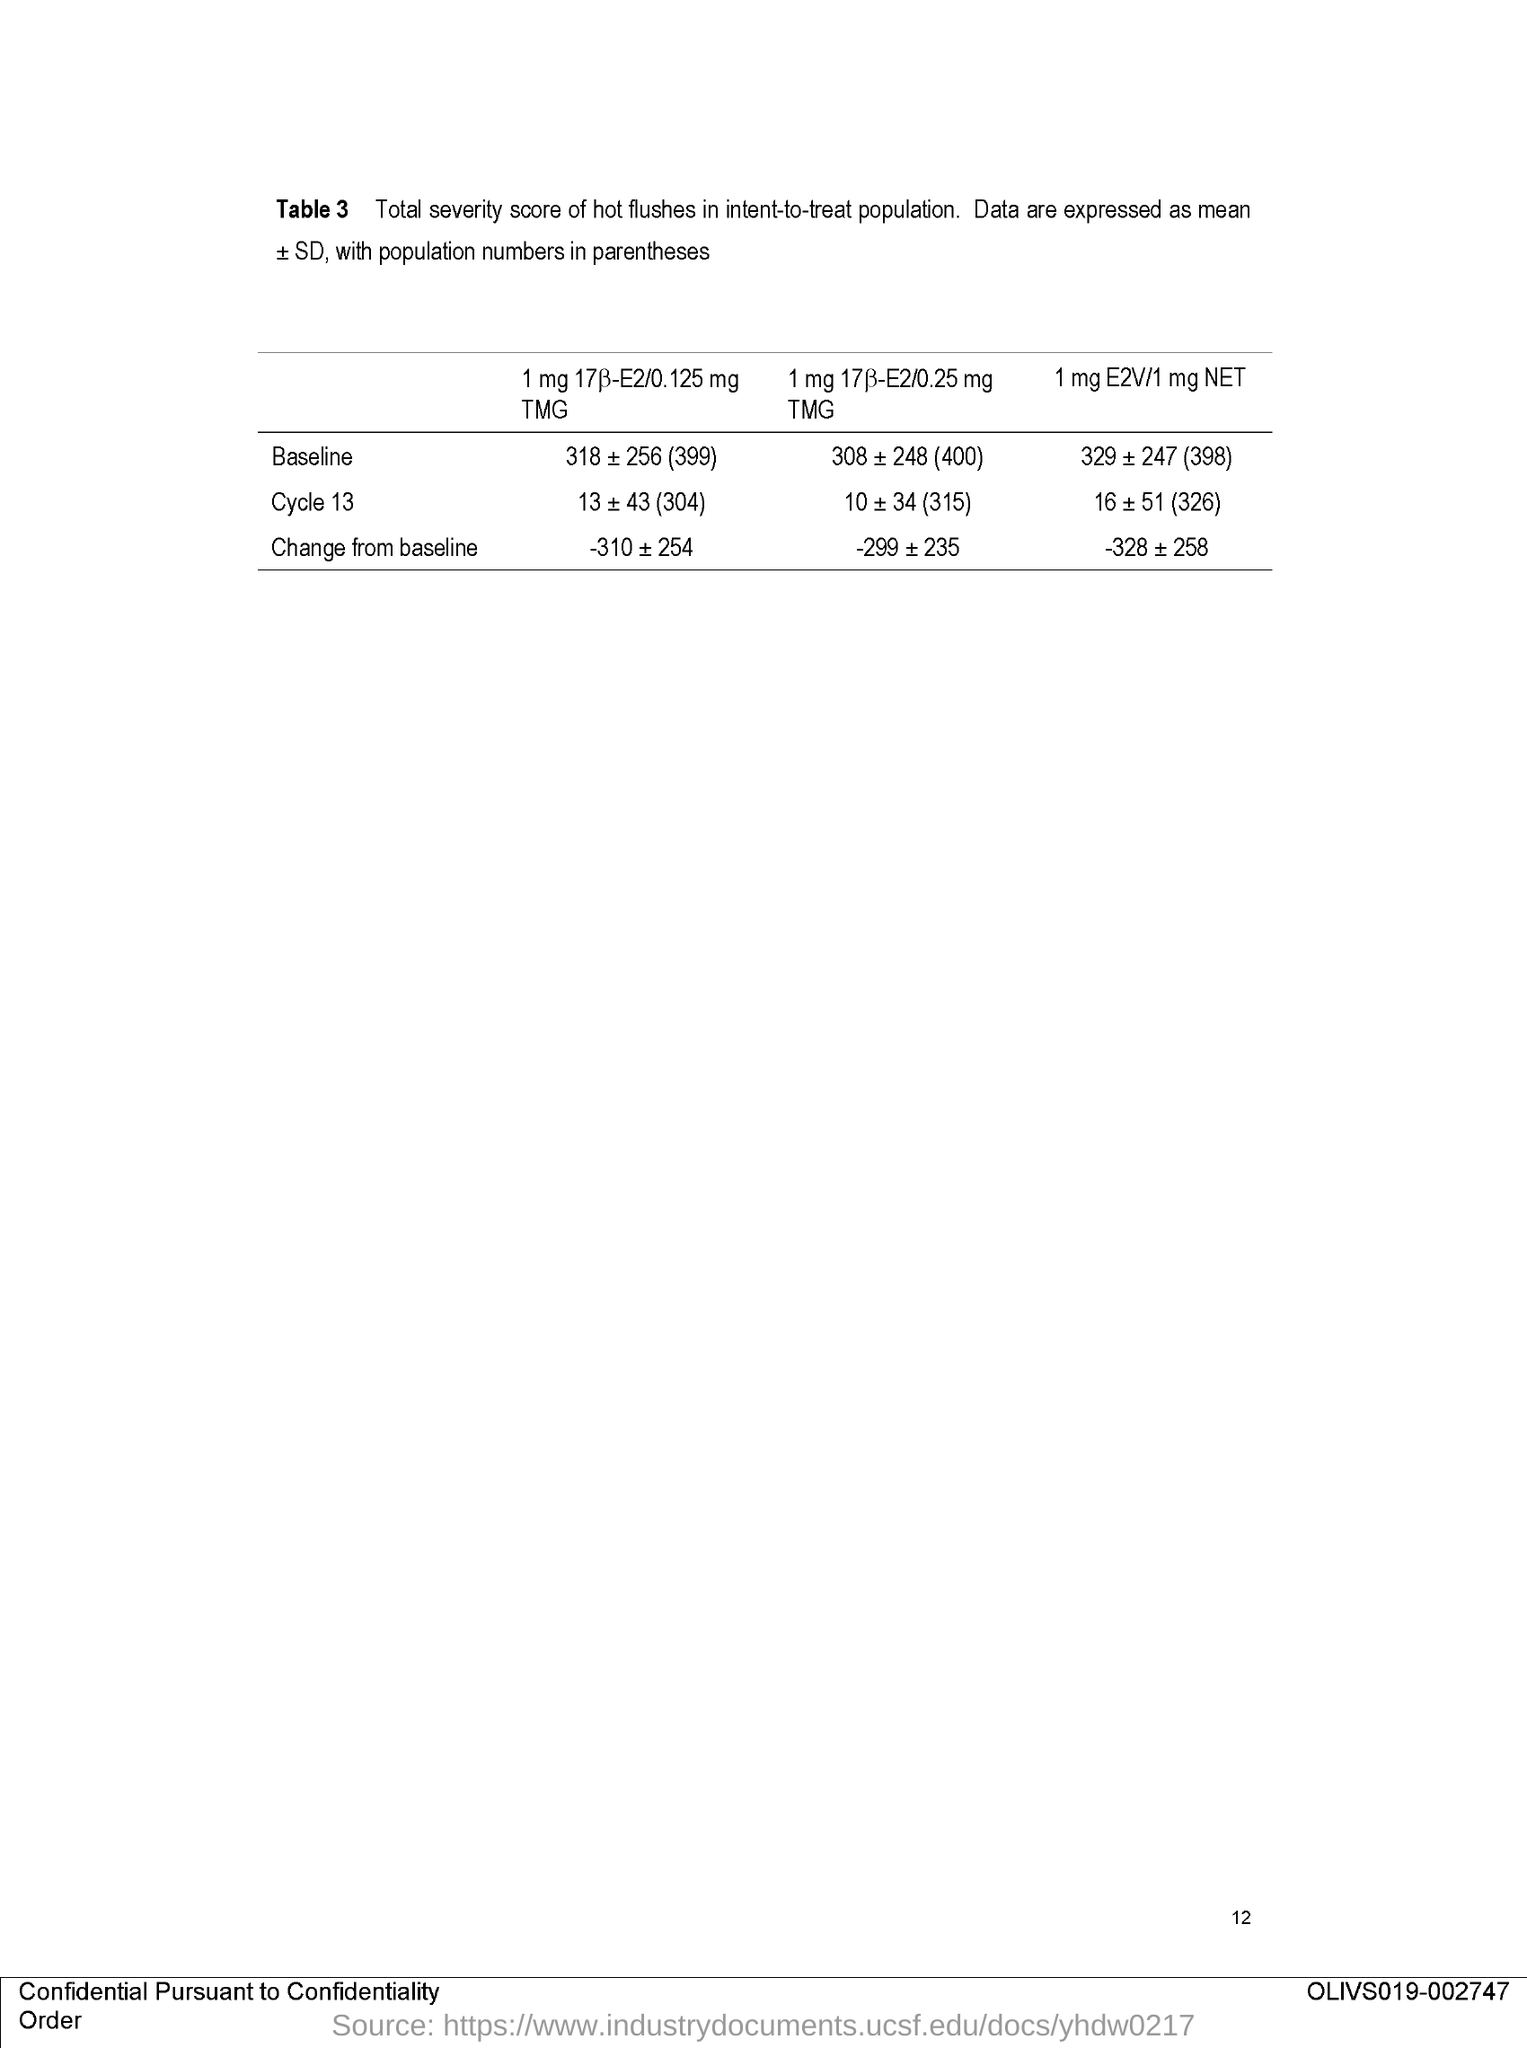What is the page no mentioned in this document?
Keep it short and to the point. 12. What does Table 3 in this document describe?
Give a very brief answer. Total severity score of hot flushes in intent-to-treat population. 